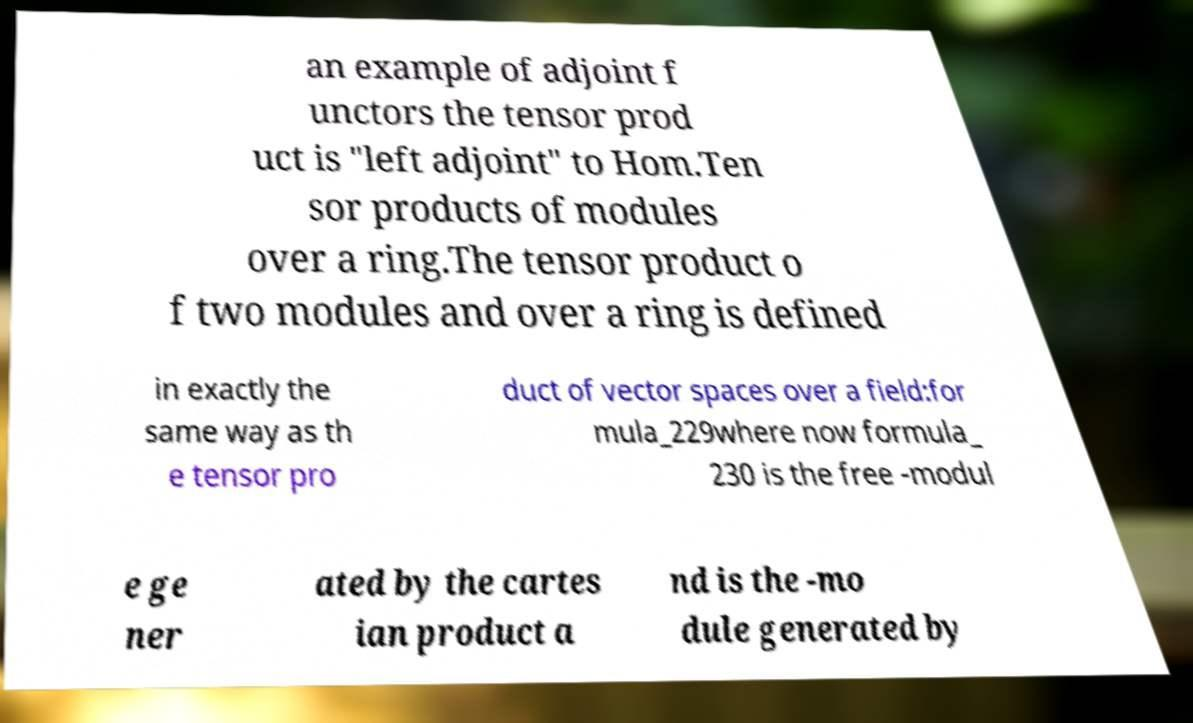Can you read and provide the text displayed in the image?This photo seems to have some interesting text. Can you extract and type it out for me? an example of adjoint f unctors the tensor prod uct is "left adjoint" to Hom.Ten sor products of modules over a ring.The tensor product o f two modules and over a ring is defined in exactly the same way as th e tensor pro duct of vector spaces over a field:for mula_229where now formula_ 230 is the free -modul e ge ner ated by the cartes ian product a nd is the -mo dule generated by 